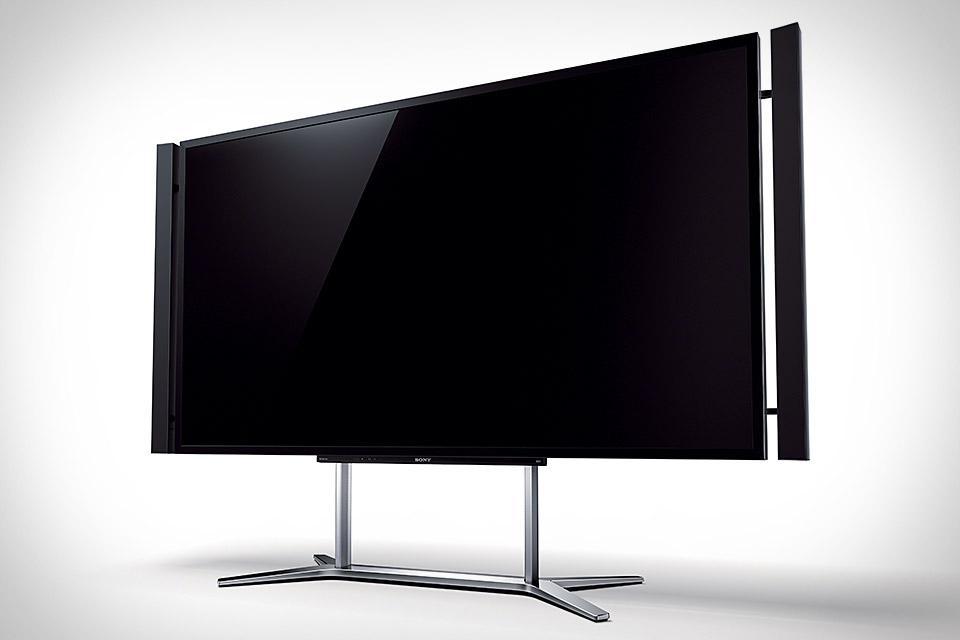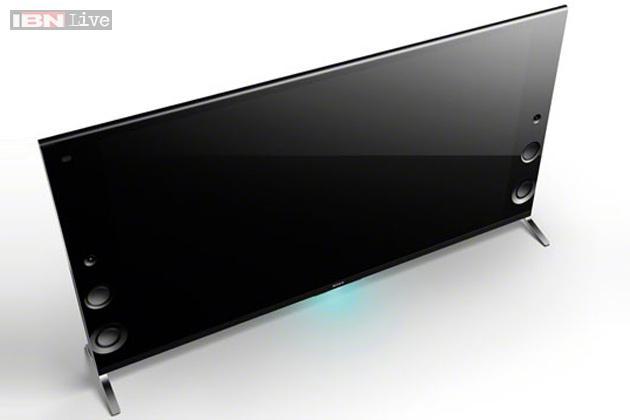The first image is the image on the left, the second image is the image on the right. Examine the images to the left and right. Is the description "Each image shows one black-screened TV elevated by chrome legs." accurate? Answer yes or no. Yes. The first image is the image on the left, the second image is the image on the right. Considering the images on both sides, is "In one of the images, the TV is showing a colorful display." valid? Answer yes or no. No. 